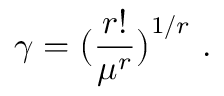Convert formula to latex. <formula><loc_0><loc_0><loc_500><loc_500>\gamma = \left ( \frac { r ! } { \mu ^ { r } } \right ) ^ { 1 / r } .</formula> 